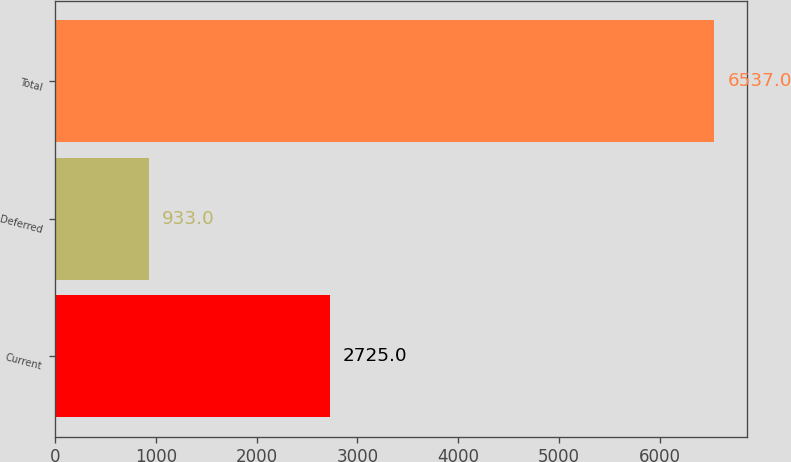Convert chart. <chart><loc_0><loc_0><loc_500><loc_500><bar_chart><fcel>Current<fcel>Deferred<fcel>Total<nl><fcel>2725<fcel>933<fcel>6537<nl></chart> 